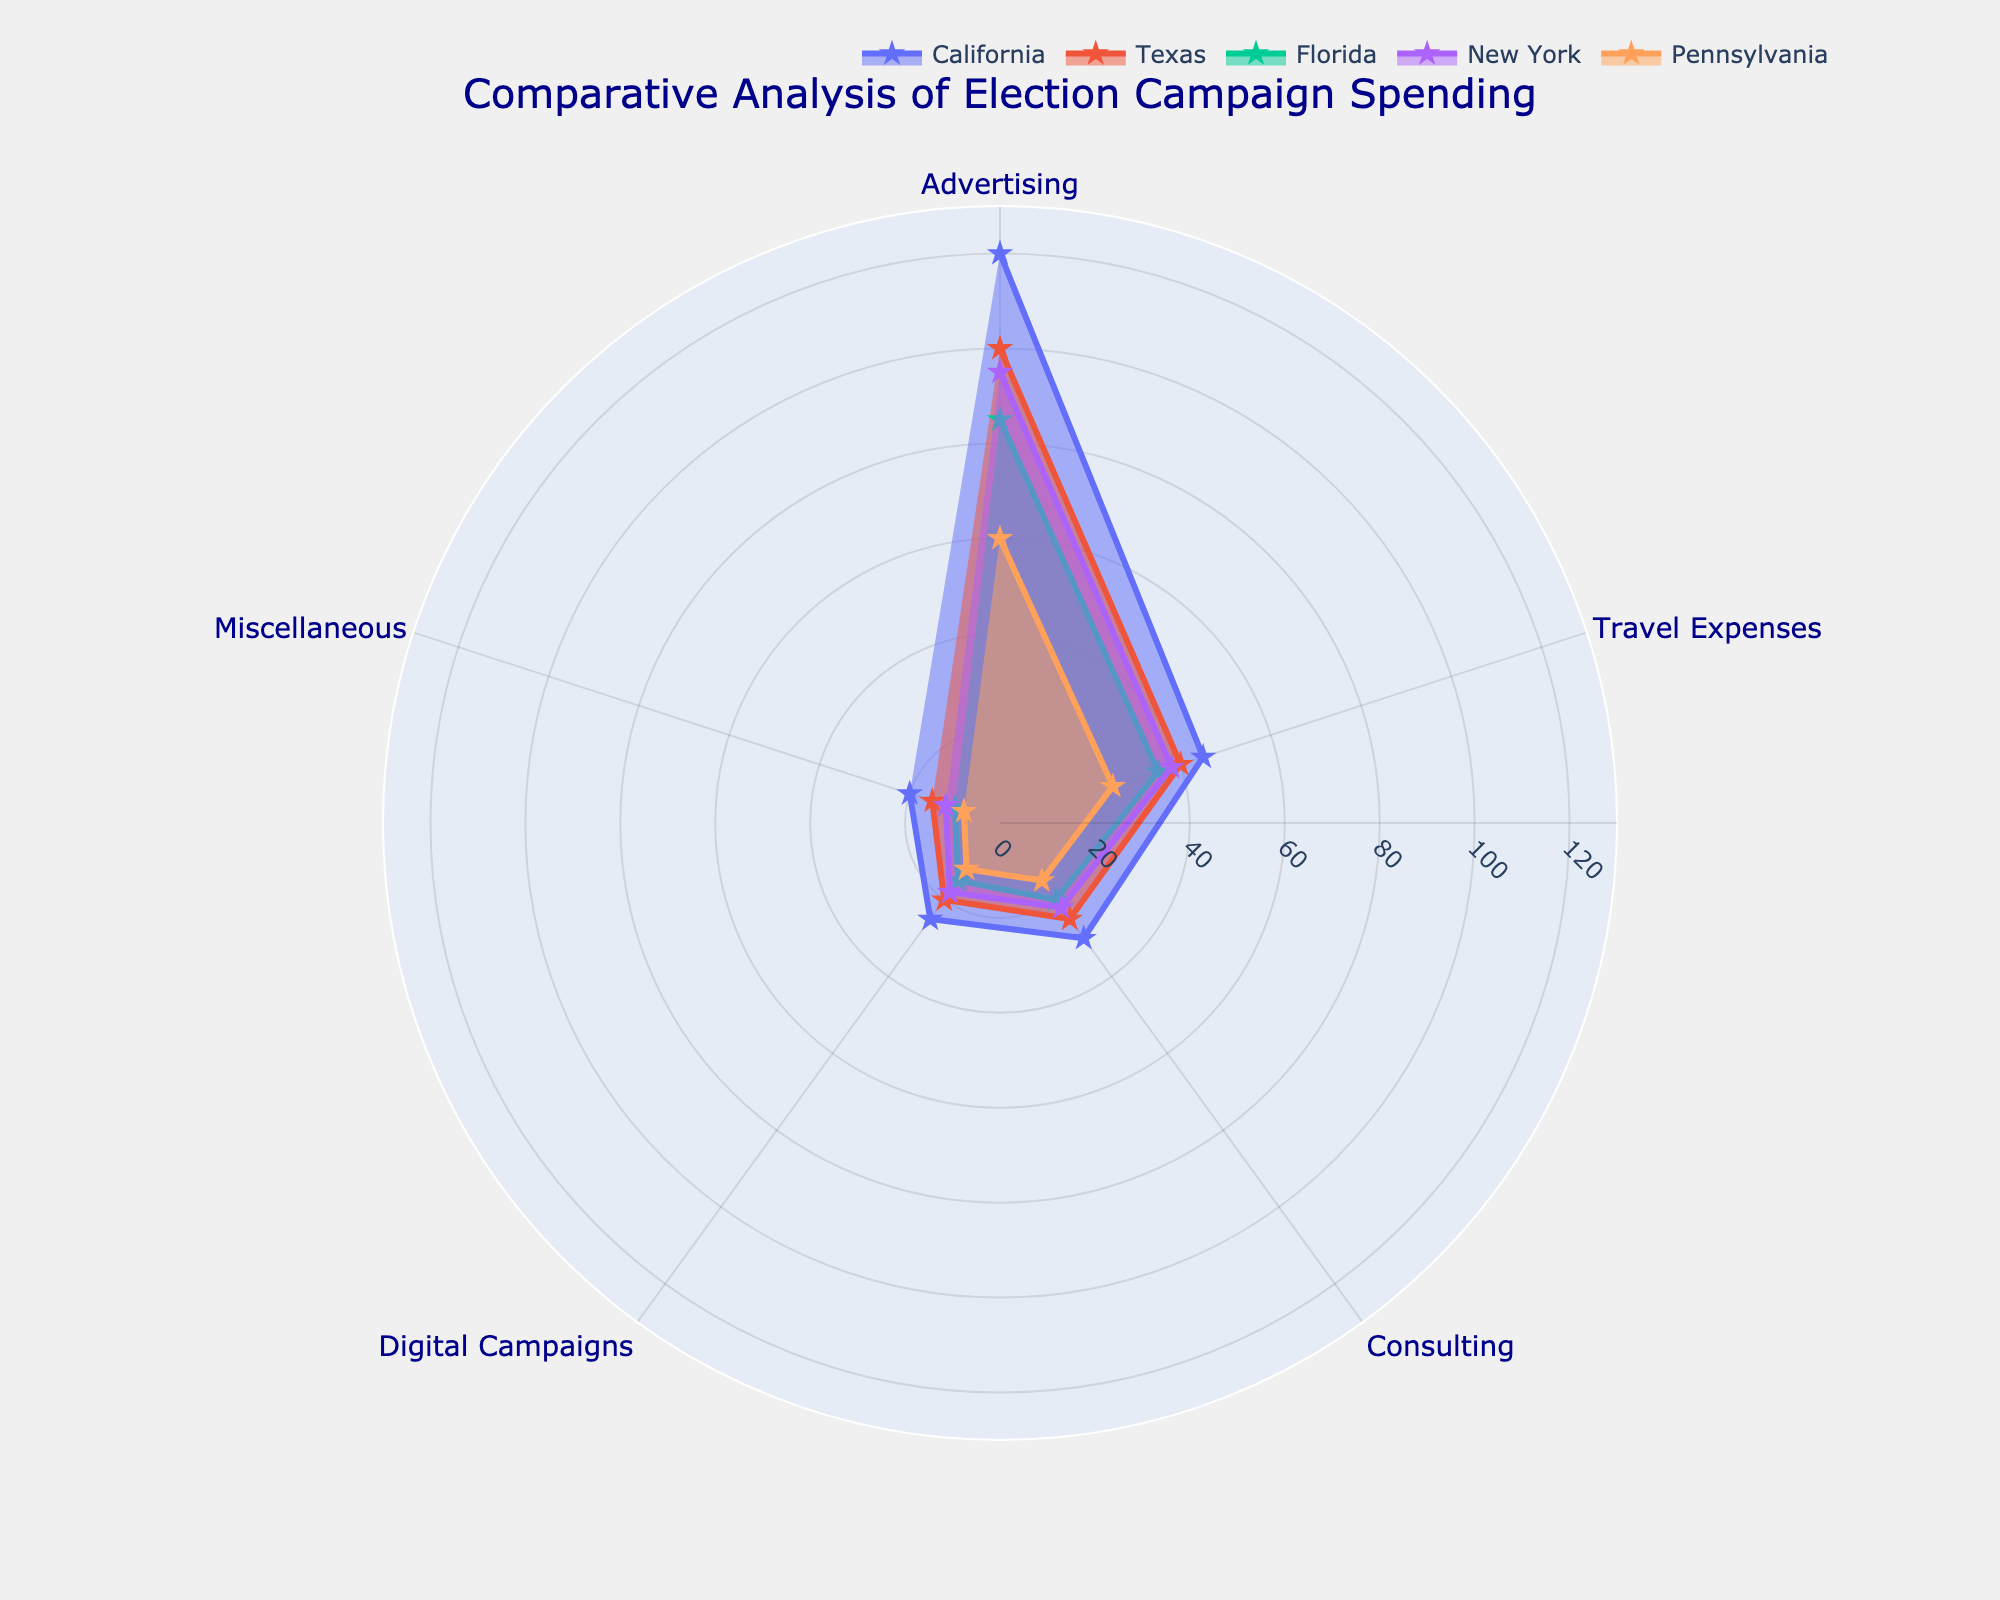What is the highest spending category in California? By looking at the figure and focusing on the plot corresponding to California, check the radial axis value of each category. The highest radial value will determine the highest spending category.
Answer: Advertising Which state has the lowest spending in the Digital Campaigns category? Compare the radial values for the Digital Campaigns category across all states shown on the figure. The state with the smallest radial value has the lowest spending in that category.
Answer: Pennsylvania How does the spending on Travel Expenses in Texas compare to New York? Check the radial axis values for the Travel Expenses category for both Texas and New York on the figure. Compare these two values to see which is higher.
Answer: Texas spends slightly more What is the total spending on Advertising across all states shown? Sum the radial axis values for the Advertising category for each state: 120 (California) + 100 (Texas) + 85 (Florida) + 95 (New York) + 60 (Pennsylvania).
Answer: 460 million USD Which state shows the most balanced spending across all categories? A state with the most balanced spending would have similar radial values for all categories. This can be visually identified by looking for a plot with less variance in the distances from the center to the points.
Answer: Florida Are the spending patterns in California and Texas more similar or different? Compare the shapes and radial values of the plots for California and Texas. Look for similar or differing patterns in the distances from the center for each category.
Answer: More different In which category does Florida's spending most differ from New York's? Compare the radial values for each category between Florida and New York. The category with the largest difference between these two states' values will be the one with the most significant difference.
Answer: Advertising What is the average spending on Consulting across the shown states? Add the radial values for the Consulting category for each state: 30 (California) + 25 (Texas) + 20 (Florida) + 22 (New York) + 15 (Pennsylvania), then divide by the number of states (5).
Answer: 22.4 million USD Which state has the highest overall campaign spending? To determine this, sum the radial values for all categories within each state's plot. The state with the highest total sum is the highest spending state.
Answer: California Does any state spend the least on both Travel Expenses and Consulting? Identify the spending for Travel Expenses and Consulting for each state separately. Compare to see if any state has the lowest values in both categories.
Answer: No 